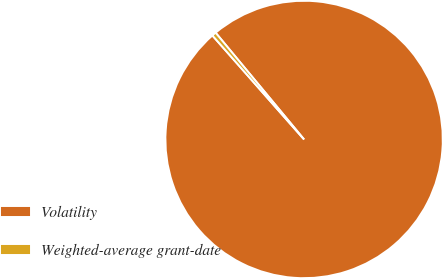Convert chart to OTSL. <chart><loc_0><loc_0><loc_500><loc_500><pie_chart><fcel>Volatility<fcel>Weighted-average grant-date<nl><fcel>99.51%<fcel>0.49%<nl></chart> 